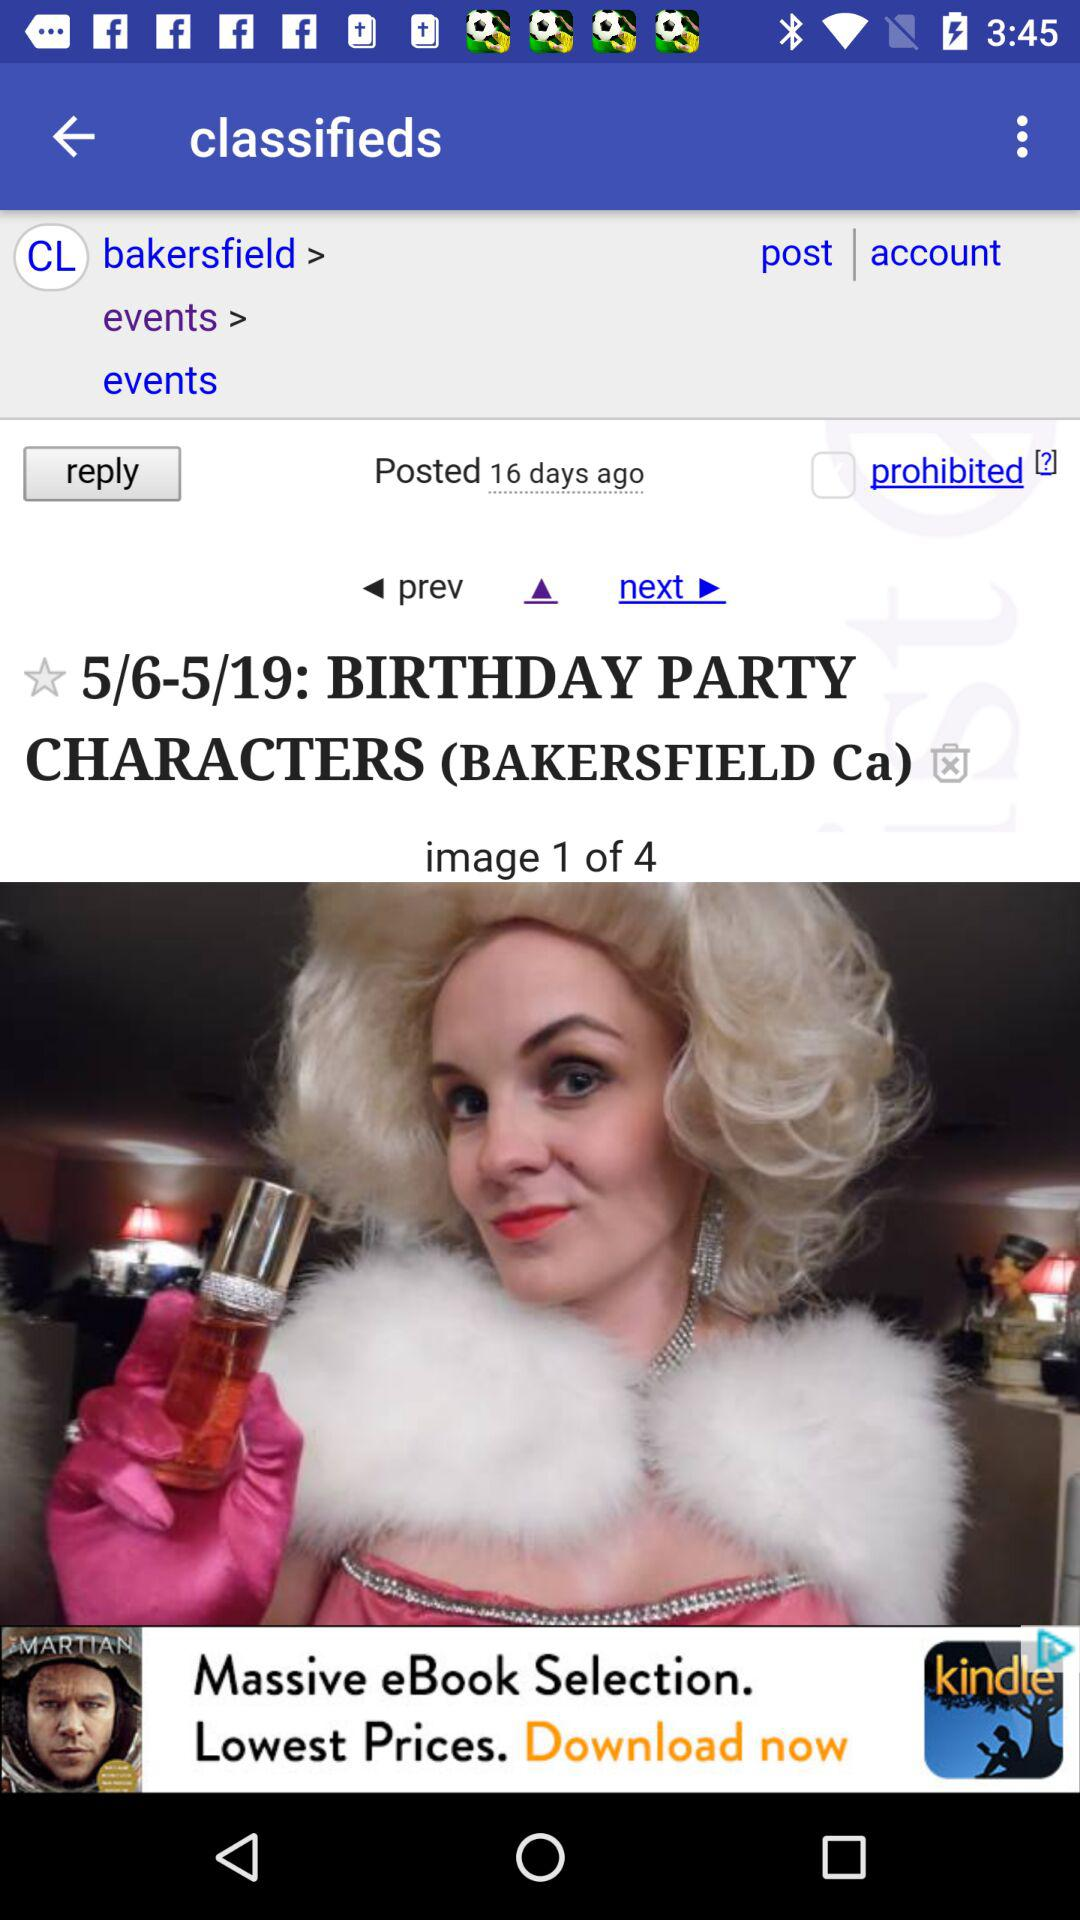Which image am I at? You are on image 1. 